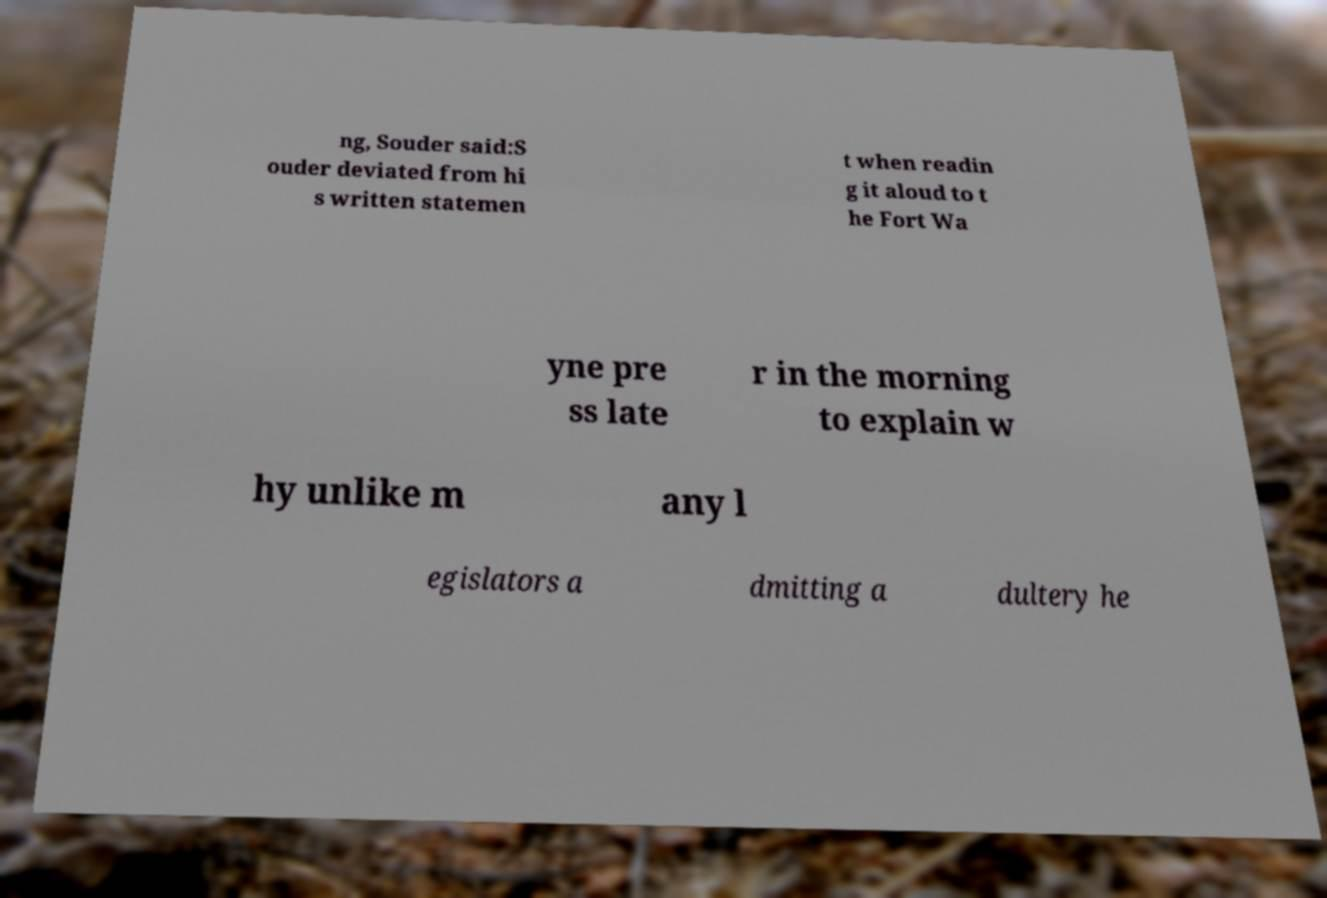There's text embedded in this image that I need extracted. Can you transcribe it verbatim? ng, Souder said:S ouder deviated from hi s written statemen t when readin g it aloud to t he Fort Wa yne pre ss late r in the morning to explain w hy unlike m any l egislators a dmitting a dultery he 